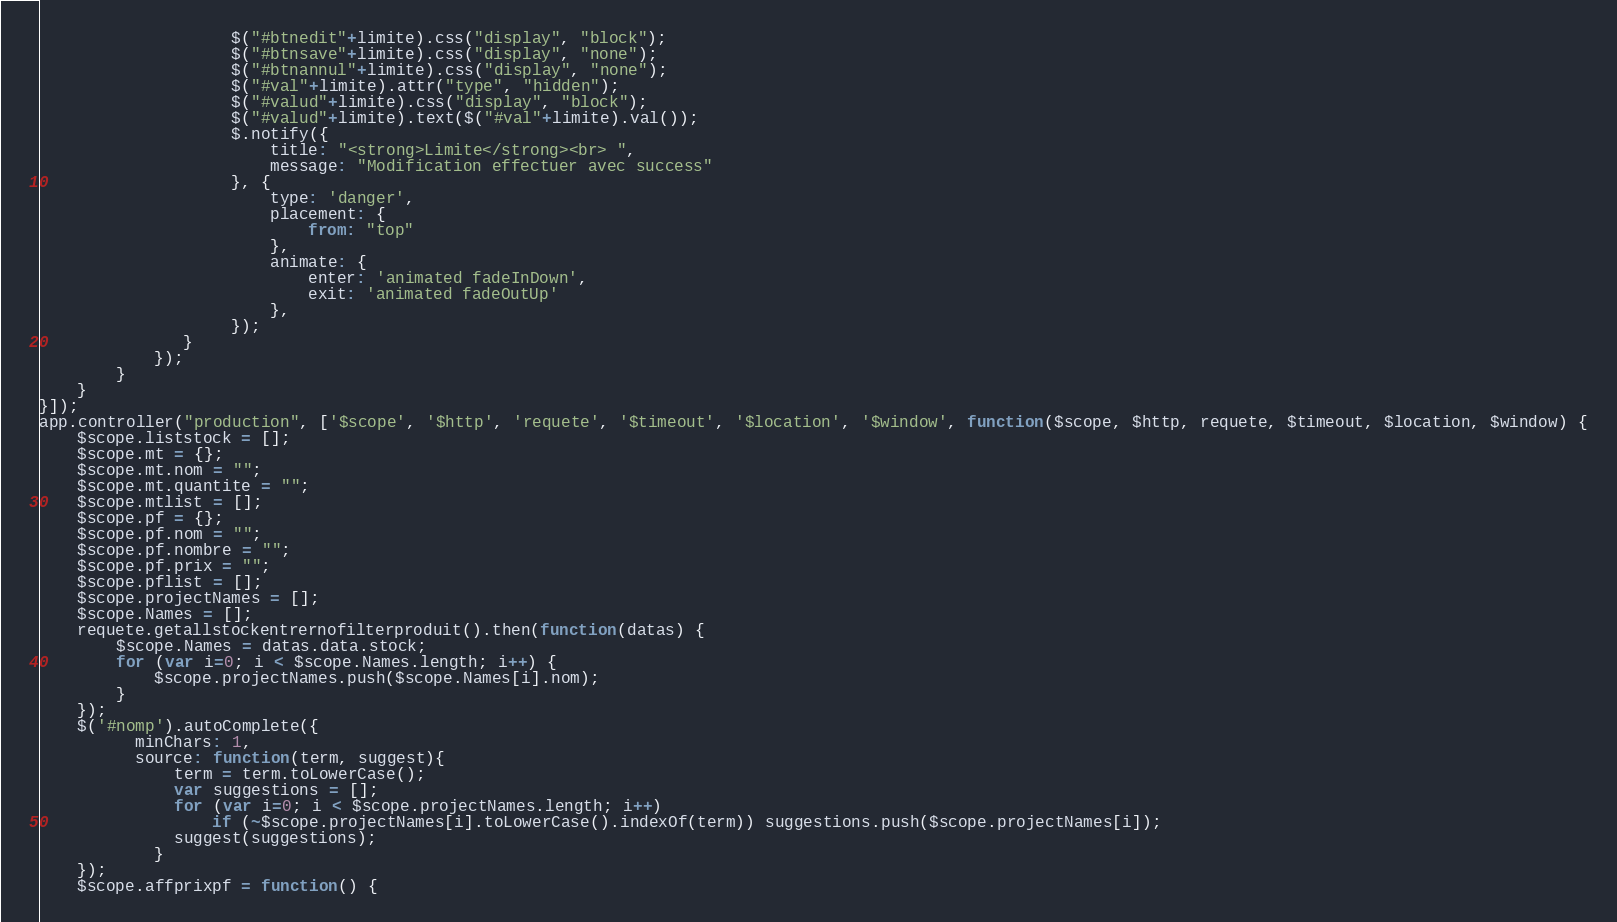<code> <loc_0><loc_0><loc_500><loc_500><_JavaScript_>                    $("#btnedit"+limite).css("display", "block");
                    $("#btnsave"+limite).css("display", "none");
                    $("#btnannul"+limite).css("display", "none");
                    $("#val"+limite).attr("type", "hidden");
                    $("#valud"+limite).css("display", "block");
                    $("#valud"+limite).text($("#val"+limite).val());
                    $.notify({
                        title: "<strong>Limite</strong><br> ",
                        message: "Modification effectuer avec success"
                    }, {
                        type: 'danger',
                        placement: {
                            from: "top"
                        },
                        animate: {
                            enter: 'animated fadeInDown',
                            exit: 'animated fadeOutUp'
                        },
                    });
               }
            }); 
        }
    }
}]);
app.controller("production", ['$scope', '$http', 'requete', '$timeout', '$location', '$window', function($scope, $http, requete, $timeout, $location, $window) {
    $scope.liststock = [];
    $scope.mt = {};
    $scope.mt.nom = "";
    $scope.mt.quantite = "";
    $scope.mtlist = [];
    $scope.pf = {};
    $scope.pf.nom = "";
    $scope.pf.nombre = "";
    $scope.pf.prix = "";
    $scope.pflist = [];
    $scope.projectNames = [];
    $scope.Names = [];
    requete.getallstockentrernofilterproduit().then(function(datas) {
        $scope.Names = datas.data.stock;
        for (var i=0; i < $scope.Names.length; i++) {
            $scope.projectNames.push($scope.Names[i].nom);
        }
    });
    $('#nomp').autoComplete({
          minChars: 1,
          source: function(term, suggest){
              term = term.toLowerCase();
              var suggestions = [];
              for (var i=0; i < $scope.projectNames.length; i++)
                  if (~$scope.projectNames[i].toLowerCase().indexOf(term)) suggestions.push($scope.projectNames[i]);
              suggest(suggestions);
            }
    });
    $scope.affprixpf = function() {</code> 